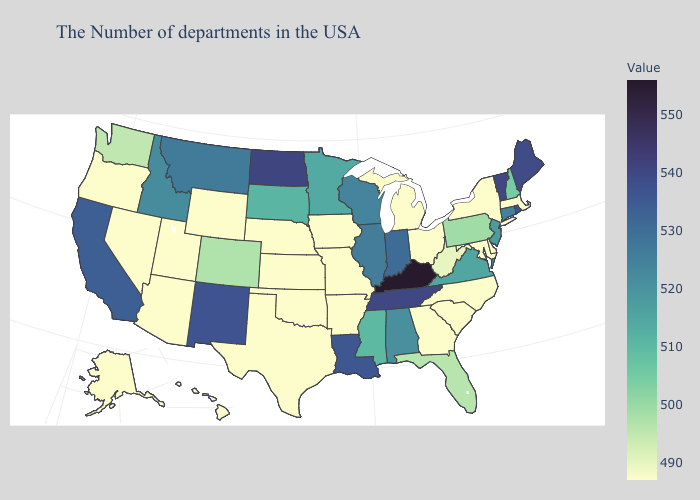Does Indiana have the lowest value in the USA?
Concise answer only. No. Among the states that border Michigan , does Ohio have the lowest value?
Answer briefly. Yes. Among the states that border Oklahoma , which have the highest value?
Short answer required. New Mexico. Is the legend a continuous bar?
Give a very brief answer. Yes. Which states have the lowest value in the MidWest?
Short answer required. Ohio, Michigan, Missouri, Iowa, Kansas, Nebraska. Is the legend a continuous bar?
Keep it brief. Yes. 